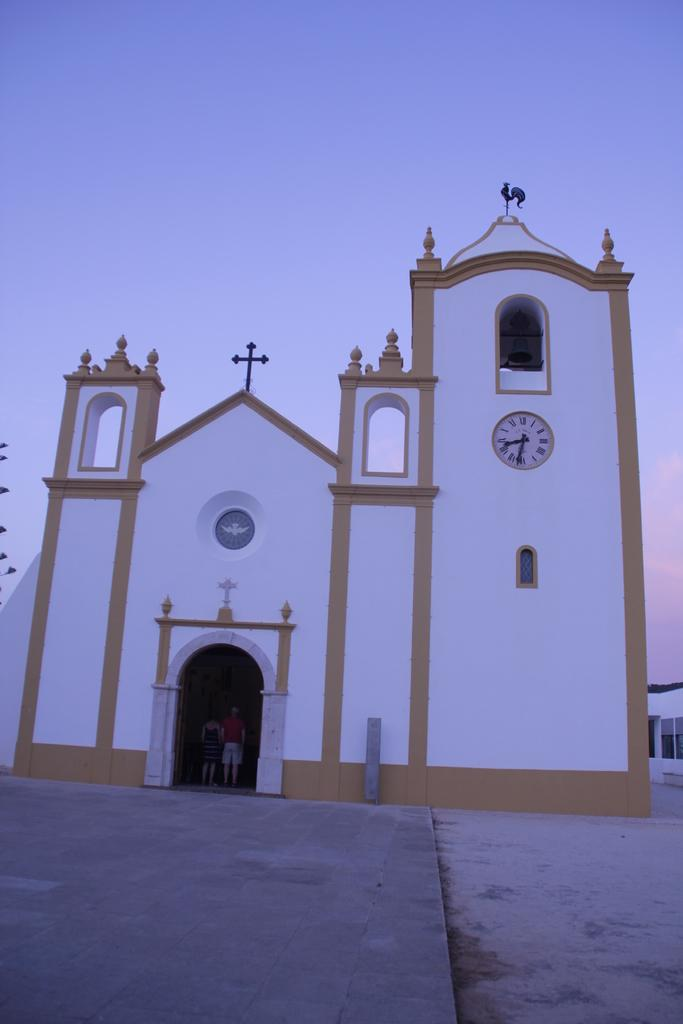What is the main subject in the middle of the image? There is a church in the middle of the image. Where is the church located in relation to the image? The church is in the foreground. What type of surface is visible at the bottom of the image? There is pavement at the bottom of the image. What can be seen on the right side of the image? There is a wall on the right side of the image. What feature is present on the wall? There is a window on the wall. What is visible at the top of the image? The sky is visible at the top of the image. What type of protest is taking place in front of the church in the image? There is no protest present in the image; it only shows a church, pavement, a wall, a window, and the sky. 